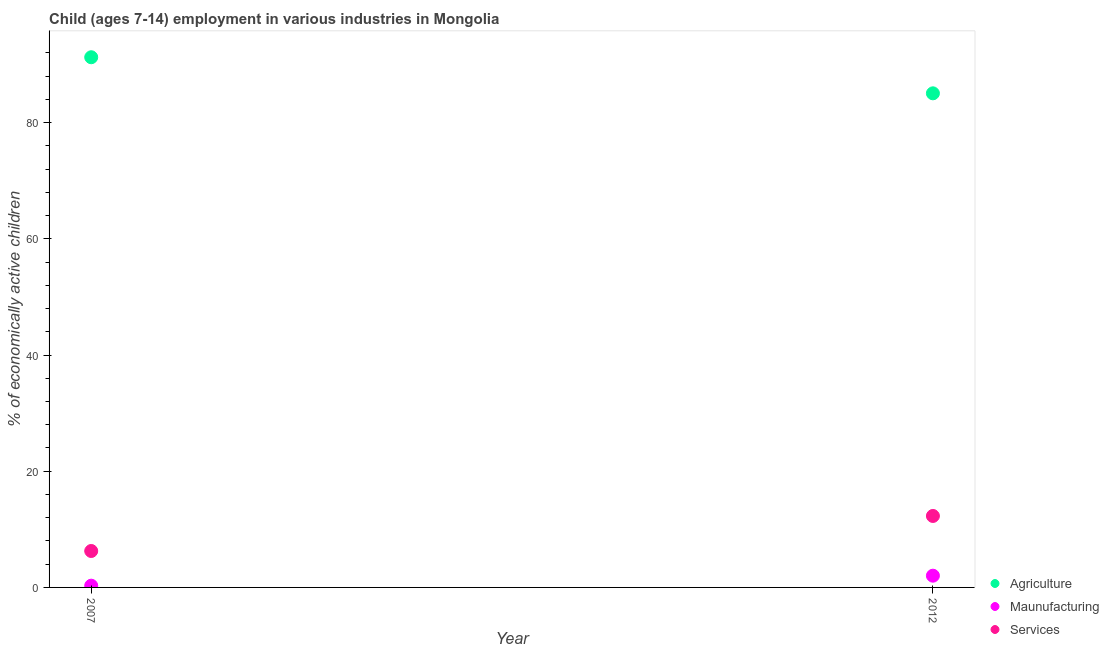What is the percentage of economically active children in manufacturing in 2007?
Ensure brevity in your answer.  0.3. Across all years, what is the maximum percentage of economically active children in agriculture?
Make the answer very short. 91.25. Across all years, what is the minimum percentage of economically active children in manufacturing?
Make the answer very short. 0.3. What is the total percentage of economically active children in manufacturing in the graph?
Your answer should be compact. 2.32. What is the difference between the percentage of economically active children in manufacturing in 2007 and that in 2012?
Offer a very short reply. -1.72. What is the difference between the percentage of economically active children in agriculture in 2007 and the percentage of economically active children in services in 2012?
Offer a very short reply. 78.95. What is the average percentage of economically active children in agriculture per year?
Offer a very short reply. 88.15. In the year 2012, what is the difference between the percentage of economically active children in manufacturing and percentage of economically active children in agriculture?
Give a very brief answer. -83.02. In how many years, is the percentage of economically active children in agriculture greater than 16 %?
Your response must be concise. 2. What is the ratio of the percentage of economically active children in agriculture in 2007 to that in 2012?
Provide a succinct answer. 1.07. Is the percentage of economically active children in agriculture in 2007 less than that in 2012?
Provide a short and direct response. No. In how many years, is the percentage of economically active children in agriculture greater than the average percentage of economically active children in agriculture taken over all years?
Give a very brief answer. 1. How many dotlines are there?
Ensure brevity in your answer.  3. Are the values on the major ticks of Y-axis written in scientific E-notation?
Offer a very short reply. No. What is the title of the graph?
Ensure brevity in your answer.  Child (ages 7-14) employment in various industries in Mongolia. Does "Ages 15-20" appear as one of the legend labels in the graph?
Your response must be concise. No. What is the label or title of the Y-axis?
Give a very brief answer. % of economically active children. What is the % of economically active children of Agriculture in 2007?
Your response must be concise. 91.25. What is the % of economically active children of Maunufacturing in 2007?
Offer a very short reply. 0.3. What is the % of economically active children of Services in 2007?
Ensure brevity in your answer.  6.27. What is the % of economically active children in Agriculture in 2012?
Make the answer very short. 85.04. What is the % of economically active children of Maunufacturing in 2012?
Your response must be concise. 2.02. What is the % of economically active children of Services in 2012?
Keep it short and to the point. 12.3. Across all years, what is the maximum % of economically active children of Agriculture?
Provide a succinct answer. 91.25. Across all years, what is the maximum % of economically active children in Maunufacturing?
Provide a short and direct response. 2.02. Across all years, what is the minimum % of economically active children in Agriculture?
Ensure brevity in your answer.  85.04. Across all years, what is the minimum % of economically active children in Services?
Your answer should be compact. 6.27. What is the total % of economically active children in Agriculture in the graph?
Ensure brevity in your answer.  176.29. What is the total % of economically active children in Maunufacturing in the graph?
Ensure brevity in your answer.  2.32. What is the total % of economically active children of Services in the graph?
Your answer should be very brief. 18.57. What is the difference between the % of economically active children of Agriculture in 2007 and that in 2012?
Offer a terse response. 6.21. What is the difference between the % of economically active children in Maunufacturing in 2007 and that in 2012?
Keep it short and to the point. -1.72. What is the difference between the % of economically active children in Services in 2007 and that in 2012?
Provide a succinct answer. -6.03. What is the difference between the % of economically active children in Agriculture in 2007 and the % of economically active children in Maunufacturing in 2012?
Provide a short and direct response. 89.23. What is the difference between the % of economically active children of Agriculture in 2007 and the % of economically active children of Services in 2012?
Keep it short and to the point. 78.95. What is the average % of economically active children of Agriculture per year?
Your answer should be compact. 88.14. What is the average % of economically active children in Maunufacturing per year?
Keep it short and to the point. 1.16. What is the average % of economically active children in Services per year?
Your answer should be compact. 9.29. In the year 2007, what is the difference between the % of economically active children in Agriculture and % of economically active children in Maunufacturing?
Keep it short and to the point. 90.95. In the year 2007, what is the difference between the % of economically active children in Agriculture and % of economically active children in Services?
Provide a short and direct response. 84.98. In the year 2007, what is the difference between the % of economically active children of Maunufacturing and % of economically active children of Services?
Your response must be concise. -5.97. In the year 2012, what is the difference between the % of economically active children of Agriculture and % of economically active children of Maunufacturing?
Provide a short and direct response. 83.02. In the year 2012, what is the difference between the % of economically active children in Agriculture and % of economically active children in Services?
Your answer should be very brief. 72.74. In the year 2012, what is the difference between the % of economically active children in Maunufacturing and % of economically active children in Services?
Provide a short and direct response. -10.28. What is the ratio of the % of economically active children in Agriculture in 2007 to that in 2012?
Your answer should be compact. 1.07. What is the ratio of the % of economically active children in Maunufacturing in 2007 to that in 2012?
Provide a succinct answer. 0.15. What is the ratio of the % of economically active children of Services in 2007 to that in 2012?
Make the answer very short. 0.51. What is the difference between the highest and the second highest % of economically active children of Agriculture?
Make the answer very short. 6.21. What is the difference between the highest and the second highest % of economically active children of Maunufacturing?
Offer a very short reply. 1.72. What is the difference between the highest and the second highest % of economically active children in Services?
Your answer should be very brief. 6.03. What is the difference between the highest and the lowest % of economically active children of Agriculture?
Your answer should be compact. 6.21. What is the difference between the highest and the lowest % of economically active children in Maunufacturing?
Your response must be concise. 1.72. What is the difference between the highest and the lowest % of economically active children in Services?
Your response must be concise. 6.03. 